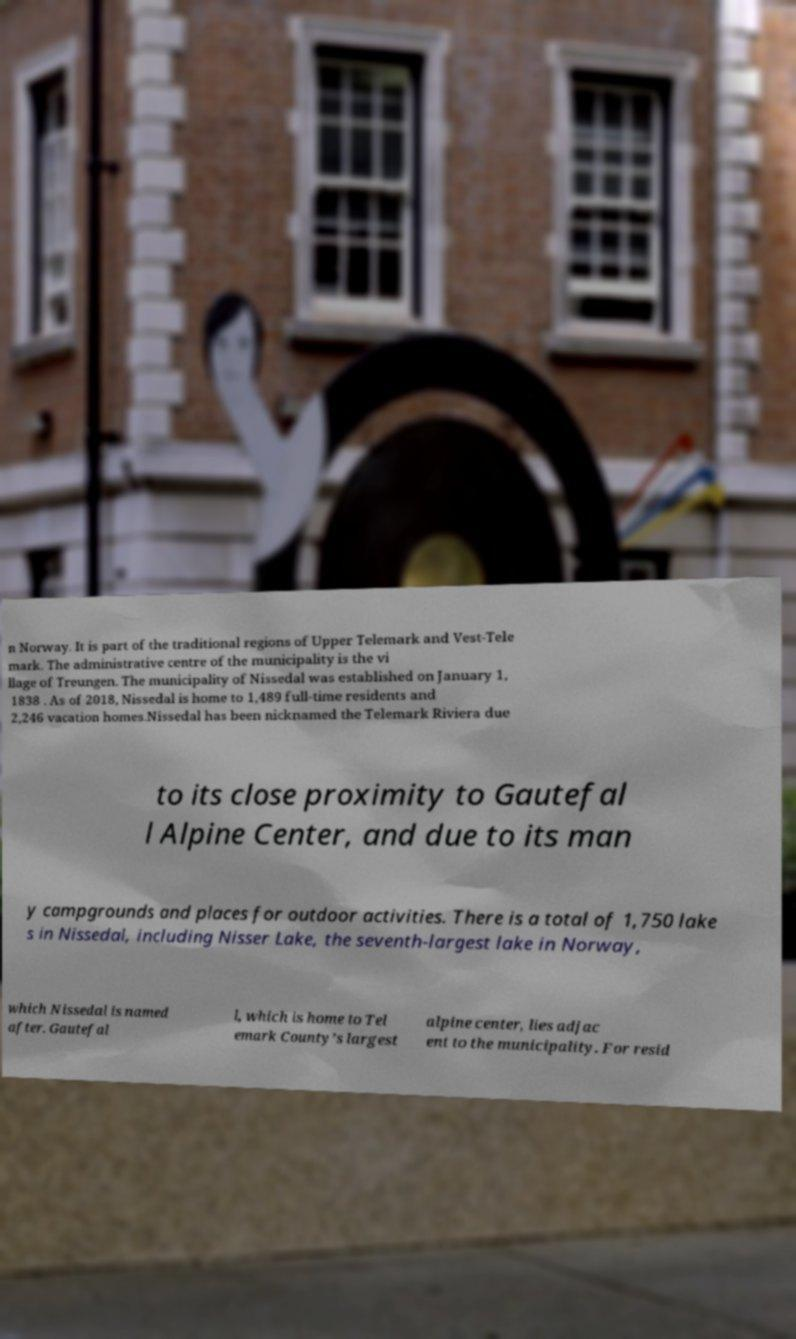Could you assist in decoding the text presented in this image and type it out clearly? n Norway. It is part of the traditional regions of Upper Telemark and Vest-Tele mark. The administrative centre of the municipality is the vi llage of Treungen. The municipality of Nissedal was established on January 1, 1838 . As of 2018, Nissedal is home to 1,489 full-time residents and 2,246 vacation homes.Nissedal has been nicknamed the Telemark Riviera due to its close proximity to Gautefal l Alpine Center, and due to its man y campgrounds and places for outdoor activities. There is a total of 1,750 lake s in Nissedal, including Nisser Lake, the seventh-largest lake in Norway, which Nissedal is named after. Gautefal l, which is home to Tel emark County’s largest alpine center, lies adjac ent to the municipality. For resid 